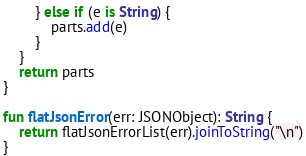<code> <loc_0><loc_0><loc_500><loc_500><_Kotlin_>        } else if (e is String) {
            parts.add(e)
        }
    }
    return parts
}

fun flatJsonError(err: JSONObject): String {
    return flatJsonErrorList(err).joinToString("\n")
}
</code> 